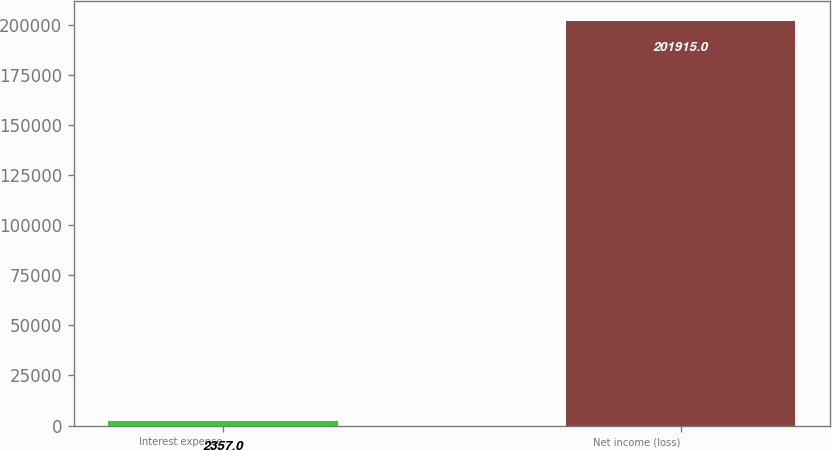Convert chart to OTSL. <chart><loc_0><loc_0><loc_500><loc_500><bar_chart><fcel>Interest expense<fcel>Net income (loss)<nl><fcel>2357<fcel>201915<nl></chart> 